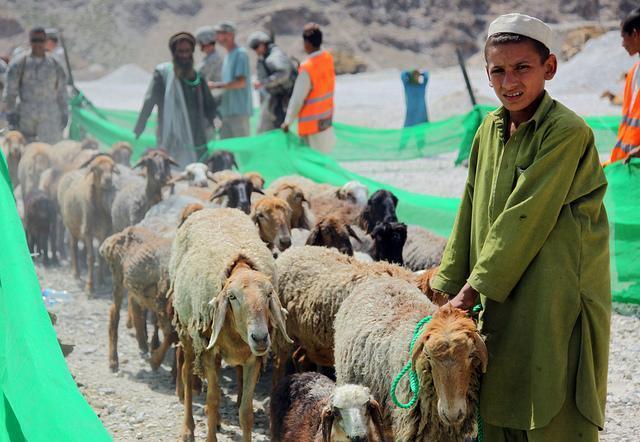How many people are there?
Give a very brief answer. 7. How many sheep can be seen?
Give a very brief answer. 9. 